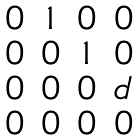Convert formula to latex. <formula><loc_0><loc_0><loc_500><loc_500>\begin{matrix} 0 & 1 & 0 & 0 \\ 0 & 0 & 1 & 0 \\ 0 & 0 & 0 & d \\ 0 & 0 & 0 & 0 \end{matrix}</formula> 